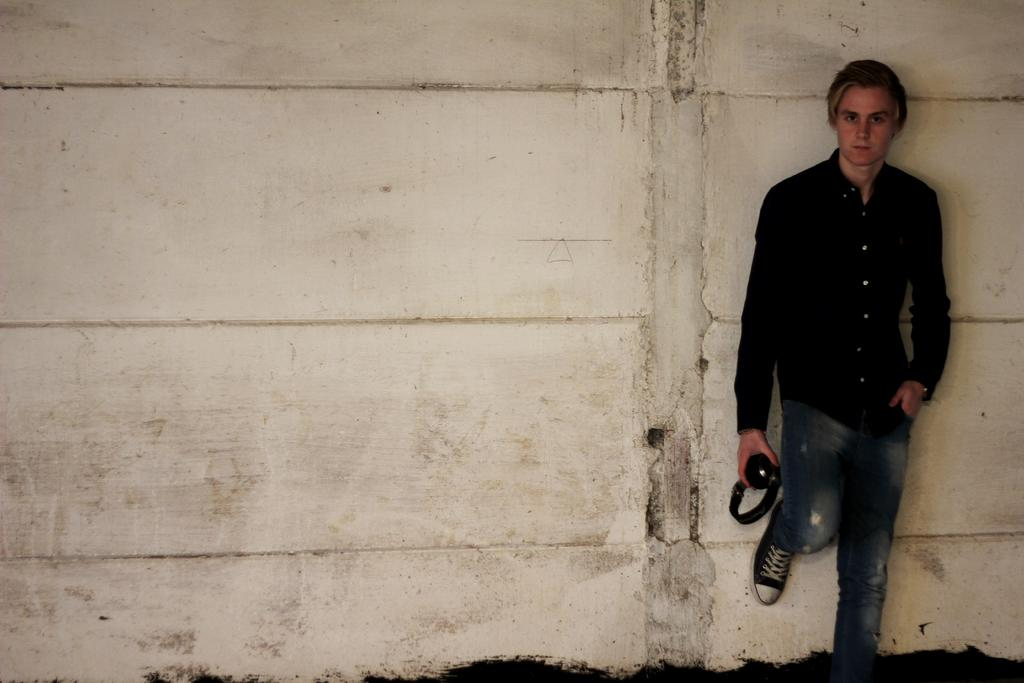What can be seen in the background of the image? There is a wall in the background of the image. Who is present in the image? There is a man in the image. What is the man wearing? The man is wearing a black shirt. What object is the man holding in his hand? The man is holding a headset in his hand. Is there a lamp illuminating the man's face in the image? There is no lamp present in the image, so it cannot be determined if it is illuminating the man's face. 